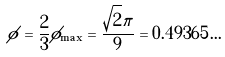<formula> <loc_0><loc_0><loc_500><loc_500>\phi = \frac { 2 } { 3 } \phi _ { \max } = \frac { \sqrt { 2 } \pi } { 9 } = 0 . 4 9 3 6 5 \dots</formula> 